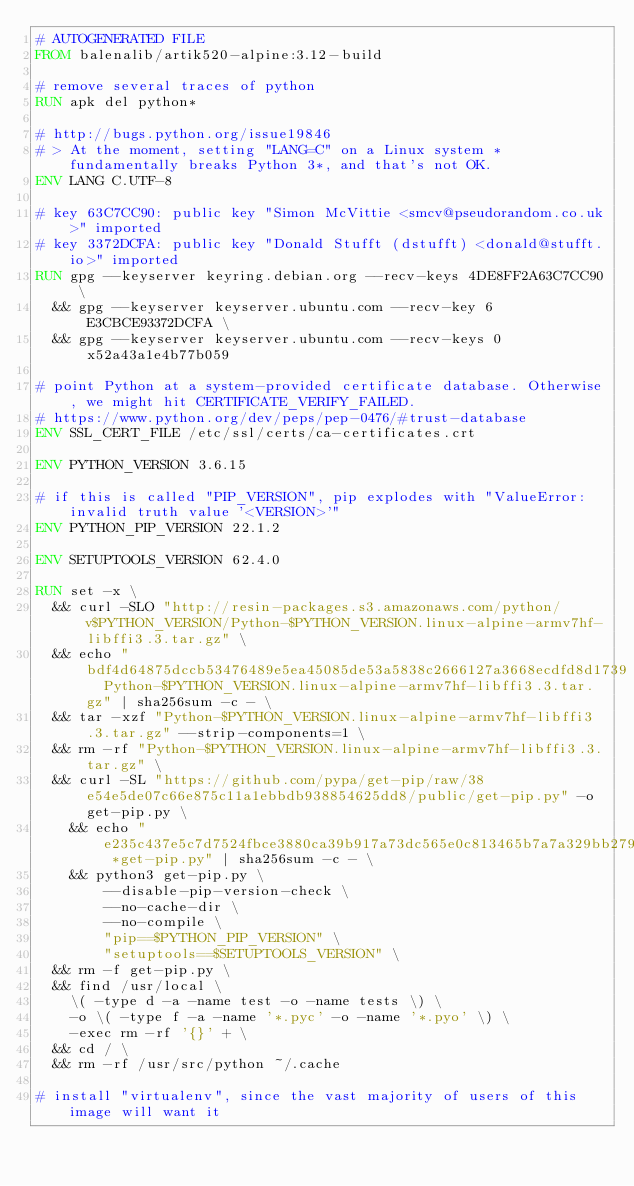Convert code to text. <code><loc_0><loc_0><loc_500><loc_500><_Dockerfile_># AUTOGENERATED FILE
FROM balenalib/artik520-alpine:3.12-build

# remove several traces of python
RUN apk del python*

# http://bugs.python.org/issue19846
# > At the moment, setting "LANG=C" on a Linux system *fundamentally breaks Python 3*, and that's not OK.
ENV LANG C.UTF-8

# key 63C7CC90: public key "Simon McVittie <smcv@pseudorandom.co.uk>" imported
# key 3372DCFA: public key "Donald Stufft (dstufft) <donald@stufft.io>" imported
RUN gpg --keyserver keyring.debian.org --recv-keys 4DE8FF2A63C7CC90 \
	&& gpg --keyserver keyserver.ubuntu.com --recv-key 6E3CBCE93372DCFA \
	&& gpg --keyserver keyserver.ubuntu.com --recv-keys 0x52a43a1e4b77b059

# point Python at a system-provided certificate database. Otherwise, we might hit CERTIFICATE_VERIFY_FAILED.
# https://www.python.org/dev/peps/pep-0476/#trust-database
ENV SSL_CERT_FILE /etc/ssl/certs/ca-certificates.crt

ENV PYTHON_VERSION 3.6.15

# if this is called "PIP_VERSION", pip explodes with "ValueError: invalid truth value '<VERSION>'"
ENV PYTHON_PIP_VERSION 22.1.2

ENV SETUPTOOLS_VERSION 62.4.0

RUN set -x \
	&& curl -SLO "http://resin-packages.s3.amazonaws.com/python/v$PYTHON_VERSION/Python-$PYTHON_VERSION.linux-alpine-armv7hf-libffi3.3.tar.gz" \
	&& echo "bdf4d64875dccb53476489e5ea45085de53a5838c2666127a3668ecdfd8d1739  Python-$PYTHON_VERSION.linux-alpine-armv7hf-libffi3.3.tar.gz" | sha256sum -c - \
	&& tar -xzf "Python-$PYTHON_VERSION.linux-alpine-armv7hf-libffi3.3.tar.gz" --strip-components=1 \
	&& rm -rf "Python-$PYTHON_VERSION.linux-alpine-armv7hf-libffi3.3.tar.gz" \
	&& curl -SL "https://github.com/pypa/get-pip/raw/38e54e5de07c66e875c11a1ebbdb938854625dd8/public/get-pip.py" -o get-pip.py \
    && echo "e235c437e5c7d7524fbce3880ca39b917a73dc565e0c813465b7a7a329bb279a *get-pip.py" | sha256sum -c - \
    && python3 get-pip.py \
        --disable-pip-version-check \
        --no-cache-dir \
        --no-compile \
        "pip==$PYTHON_PIP_VERSION" \
        "setuptools==$SETUPTOOLS_VERSION" \
	&& rm -f get-pip.py \
	&& find /usr/local \
		\( -type d -a -name test -o -name tests \) \
		-o \( -type f -a -name '*.pyc' -o -name '*.pyo' \) \
		-exec rm -rf '{}' + \
	&& cd / \
	&& rm -rf /usr/src/python ~/.cache

# install "virtualenv", since the vast majority of users of this image will want it</code> 